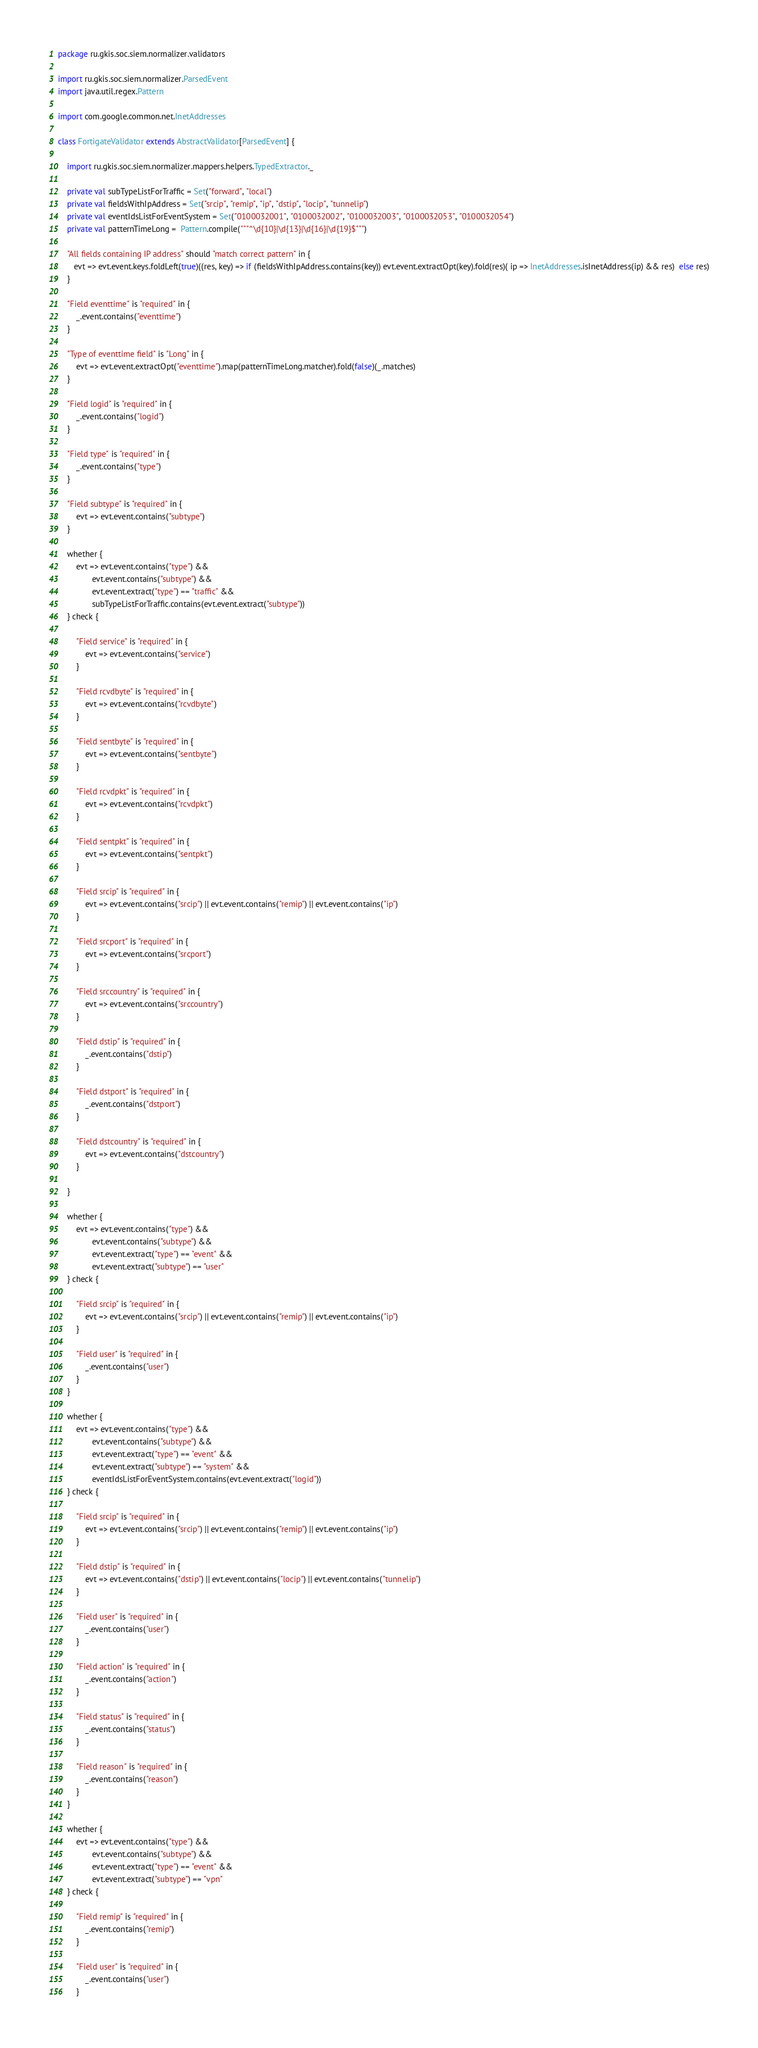<code> <loc_0><loc_0><loc_500><loc_500><_Scala_>package ru.gkis.soc.siem.normalizer.validators

import ru.gkis.soc.siem.normalizer.ParsedEvent
import java.util.regex.Pattern

import com.google.common.net.InetAddresses

class FortigateValidator extends AbstractValidator[ParsedEvent] {

    import ru.gkis.soc.siem.normalizer.mappers.helpers.TypedExtractor._

    private val subTypeListForTraffic = Set("forward", "local")
    private val fieldsWithIpAddress = Set("srcip", "remip", "ip", "dstip", "locip", "tunnelip")
    private val eventIdsListForEventSystem = Set("0100032001", "0100032002", "0100032003", "0100032053", "0100032054")
    private val patternTimeLong =  Pattern.compile("""^\d{10}|\d{13}|\d{16}|\d{19}$""")

    "All fields containing IP address" should "match correct pattern" in {
       evt => evt.event.keys.foldLeft(true)((res, key) => if (fieldsWithIpAddress.contains(key)) evt.event.extractOpt(key).fold(res)( ip => InetAddresses.isInetAddress(ip) && res)  else res)
    }

    "Field eventtime" is "required" in {
        _.event.contains("eventtime")
    }

    "Type of eventtime field" is "Long" in {
        evt => evt.event.extractOpt("eventtime").map(patternTimeLong.matcher).fold(false)(_.matches)
    }

    "Field logid" is "required" in {
        _.event.contains("logid")
    }

    "Field type" is "required" in {
        _.event.contains("type")
    }

    "Field subtype" is "required" in {
        evt => evt.event.contains("subtype")
    }

    whether {
        evt => evt.event.contains("type") &&
               evt.event.contains("subtype") &&
               evt.event.extract("type") == "traffic" &&
               subTypeListForTraffic.contains(evt.event.extract("subtype"))
    } check {

        "Field service" is "required" in {
            evt => evt.event.contains("service")
        }

        "Field rcvdbyte" is "required" in {
            evt => evt.event.contains("rcvdbyte")
        }

        "Field sentbyte" is "required" in {
            evt => evt.event.contains("sentbyte")
        }

        "Field rcvdpkt" is "required" in {
            evt => evt.event.contains("rcvdpkt")
        }

        "Field sentpkt" is "required" in {
            evt => evt.event.contains("sentpkt")
        }

        "Field srcip" is "required" in {
            evt => evt.event.contains("srcip") || evt.event.contains("remip") || evt.event.contains("ip")
        }

        "Field srcport" is "required" in {
            evt => evt.event.contains("srcport")
        }

        "Field srccountry" is "required" in {
            evt => evt.event.contains("srccountry")
        }

        "Field dstip" is "required" in {
            _.event.contains("dstip")
        }

        "Field dstport" is "required" in {
            _.event.contains("dstport")
        }

        "Field dstcountry" is "required" in {
            evt => evt.event.contains("dstcountry")
        }

    }

    whether {
        evt => evt.event.contains("type") &&
               evt.event.contains("subtype") &&
               evt.event.extract("type") == "event" &&
               evt.event.extract("subtype") == "user"
    } check {

        "Field srcip" is "required" in {
            evt => evt.event.contains("srcip") || evt.event.contains("remip") || evt.event.contains("ip")
        }

        "Field user" is "required" in {
            _.event.contains("user")
        }
    }

    whether {
        evt => evt.event.contains("type") &&
               evt.event.contains("subtype") &&
               evt.event.extract("type") == "event" &&
               evt.event.extract("subtype") == "system" &&
               eventIdsListForEventSystem.contains(evt.event.extract("logid"))
    } check {

        "Field srcip" is "required" in {
            evt => evt.event.contains("srcip") || evt.event.contains("remip") || evt.event.contains("ip")
        }

        "Field dstip" is "required" in {
            evt => evt.event.contains("dstip") || evt.event.contains("locip") || evt.event.contains("tunnelip")
        }

        "Field user" is "required" in {
            _.event.contains("user")
        }

        "Field action" is "required" in {
            _.event.contains("action")
        }

        "Field status" is "required" in {
            _.event.contains("status")
        }

        "Field reason" is "required" in {
            _.event.contains("reason")
        }
    }

    whether {
        evt => evt.event.contains("type") &&
               evt.event.contains("subtype") &&
               evt.event.extract("type") == "event" &&
               evt.event.extract("subtype") == "vpn"
    } check {

        "Field remip" is "required" in {
            _.event.contains("remip")
        }

        "Field user" is "required" in {
            _.event.contains("user")
        }</code> 